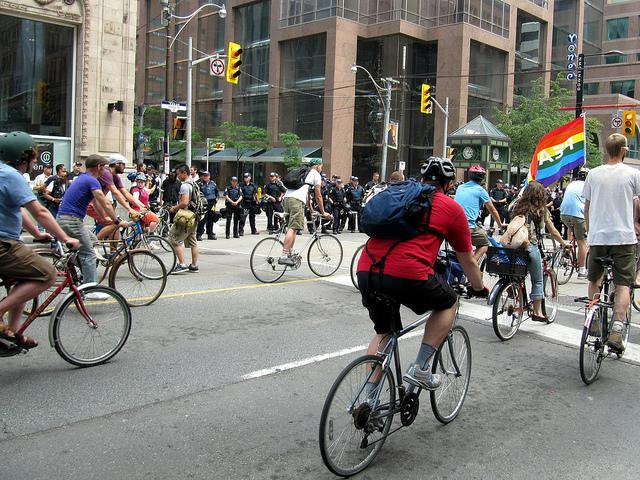Why are the men in uniforms standing by the road? protect 